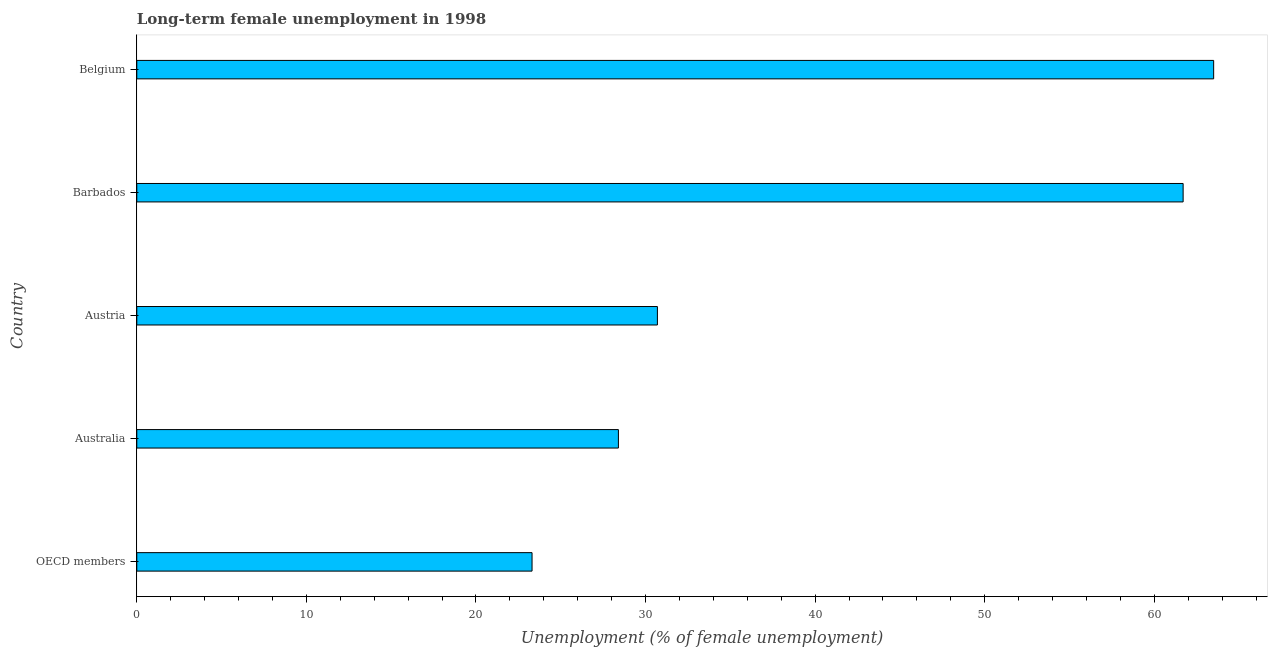Does the graph contain grids?
Offer a very short reply. No. What is the title of the graph?
Provide a succinct answer. Long-term female unemployment in 1998. What is the label or title of the X-axis?
Provide a short and direct response. Unemployment (% of female unemployment). What is the label or title of the Y-axis?
Offer a very short reply. Country. What is the long-term female unemployment in Australia?
Keep it short and to the point. 28.4. Across all countries, what is the maximum long-term female unemployment?
Offer a very short reply. 63.5. Across all countries, what is the minimum long-term female unemployment?
Keep it short and to the point. 23.31. In which country was the long-term female unemployment minimum?
Your answer should be compact. OECD members. What is the sum of the long-term female unemployment?
Keep it short and to the point. 207.61. What is the difference between the long-term female unemployment in Austria and Belgium?
Provide a succinct answer. -32.8. What is the average long-term female unemployment per country?
Your response must be concise. 41.52. What is the median long-term female unemployment?
Offer a terse response. 30.7. What is the ratio of the long-term female unemployment in Barbados to that in OECD members?
Your response must be concise. 2.65. Is the sum of the long-term female unemployment in Austria and OECD members greater than the maximum long-term female unemployment across all countries?
Offer a very short reply. No. What is the difference between the highest and the lowest long-term female unemployment?
Make the answer very short. 40.19. In how many countries, is the long-term female unemployment greater than the average long-term female unemployment taken over all countries?
Ensure brevity in your answer.  2. How many bars are there?
Make the answer very short. 5. Are all the bars in the graph horizontal?
Offer a very short reply. Yes. How many countries are there in the graph?
Provide a short and direct response. 5. What is the difference between two consecutive major ticks on the X-axis?
Your answer should be very brief. 10. Are the values on the major ticks of X-axis written in scientific E-notation?
Your answer should be very brief. No. What is the Unemployment (% of female unemployment) of OECD members?
Ensure brevity in your answer.  23.31. What is the Unemployment (% of female unemployment) of Australia?
Provide a succinct answer. 28.4. What is the Unemployment (% of female unemployment) in Austria?
Your answer should be compact. 30.7. What is the Unemployment (% of female unemployment) in Barbados?
Your response must be concise. 61.7. What is the Unemployment (% of female unemployment) of Belgium?
Provide a succinct answer. 63.5. What is the difference between the Unemployment (% of female unemployment) in OECD members and Australia?
Offer a very short reply. -5.09. What is the difference between the Unemployment (% of female unemployment) in OECD members and Austria?
Make the answer very short. -7.39. What is the difference between the Unemployment (% of female unemployment) in OECD members and Barbados?
Your response must be concise. -38.39. What is the difference between the Unemployment (% of female unemployment) in OECD members and Belgium?
Offer a terse response. -40.19. What is the difference between the Unemployment (% of female unemployment) in Australia and Barbados?
Keep it short and to the point. -33.3. What is the difference between the Unemployment (% of female unemployment) in Australia and Belgium?
Make the answer very short. -35.1. What is the difference between the Unemployment (% of female unemployment) in Austria and Barbados?
Provide a short and direct response. -31. What is the difference between the Unemployment (% of female unemployment) in Austria and Belgium?
Give a very brief answer. -32.8. What is the difference between the Unemployment (% of female unemployment) in Barbados and Belgium?
Provide a short and direct response. -1.8. What is the ratio of the Unemployment (% of female unemployment) in OECD members to that in Australia?
Ensure brevity in your answer.  0.82. What is the ratio of the Unemployment (% of female unemployment) in OECD members to that in Austria?
Provide a short and direct response. 0.76. What is the ratio of the Unemployment (% of female unemployment) in OECD members to that in Barbados?
Provide a succinct answer. 0.38. What is the ratio of the Unemployment (% of female unemployment) in OECD members to that in Belgium?
Ensure brevity in your answer.  0.37. What is the ratio of the Unemployment (% of female unemployment) in Australia to that in Austria?
Offer a very short reply. 0.93. What is the ratio of the Unemployment (% of female unemployment) in Australia to that in Barbados?
Give a very brief answer. 0.46. What is the ratio of the Unemployment (% of female unemployment) in Australia to that in Belgium?
Provide a short and direct response. 0.45. What is the ratio of the Unemployment (% of female unemployment) in Austria to that in Barbados?
Ensure brevity in your answer.  0.5. What is the ratio of the Unemployment (% of female unemployment) in Austria to that in Belgium?
Your answer should be compact. 0.48. 